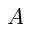Convert formula to latex. <formula><loc_0><loc_0><loc_500><loc_500>A</formula> 